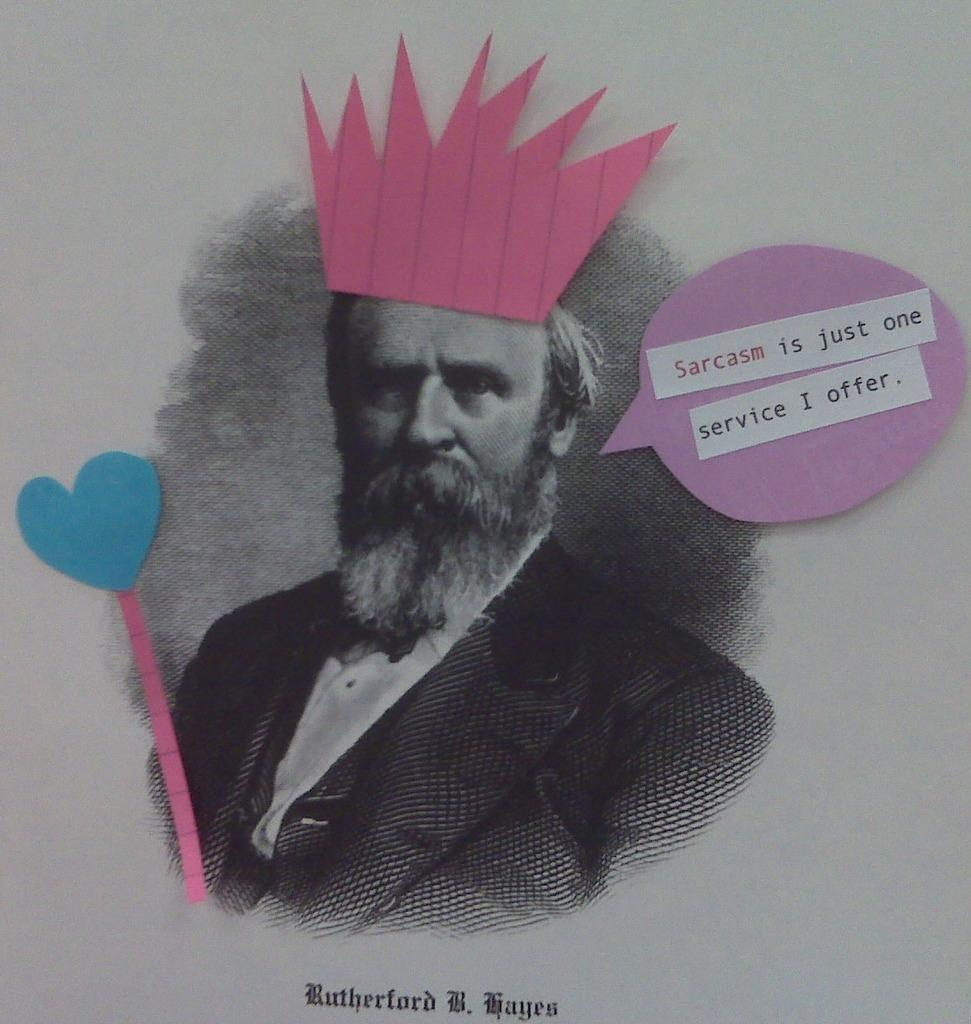What is the main object in the image? There is a paper in the image. What is depicted on the paper? There is a picture of a person on the paper. What else can be found on the paper? There is text and stickers on the paper. What type of cable is connected to the person in the image? There is no cable connected to the person in the image, as it is a picture on a paper. What month is highlighted on the calendar in the image? There is no calendar present in the image; it only features a paper with a picture, text, and stickers. 